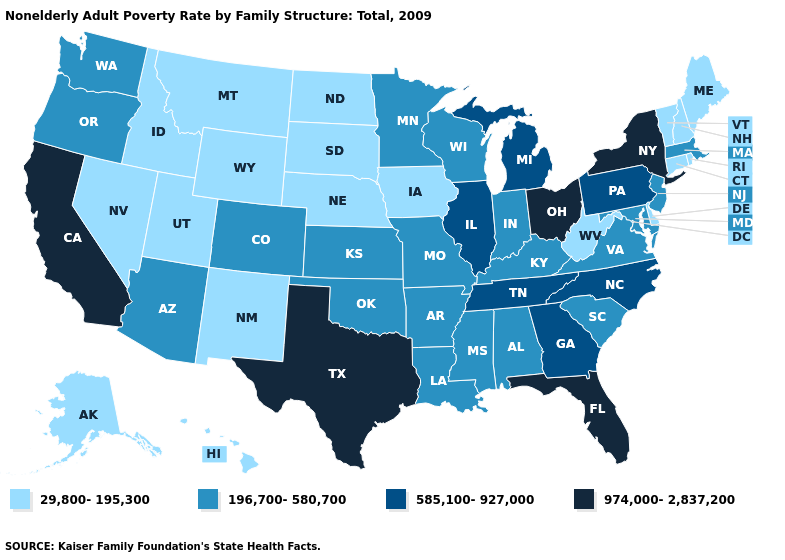What is the value of Michigan?
Be succinct. 585,100-927,000. Among the states that border Massachusetts , does Vermont have the highest value?
Give a very brief answer. No. Name the states that have a value in the range 29,800-195,300?
Concise answer only. Alaska, Connecticut, Delaware, Hawaii, Idaho, Iowa, Maine, Montana, Nebraska, Nevada, New Hampshire, New Mexico, North Dakota, Rhode Island, South Dakota, Utah, Vermont, West Virginia, Wyoming. What is the value of Washington?
Short answer required. 196,700-580,700. Does Idaho have a higher value than Iowa?
Give a very brief answer. No. Among the states that border Illinois , does Iowa have the highest value?
Answer briefly. No. What is the highest value in the USA?
Concise answer only. 974,000-2,837,200. Name the states that have a value in the range 29,800-195,300?
Write a very short answer. Alaska, Connecticut, Delaware, Hawaii, Idaho, Iowa, Maine, Montana, Nebraska, Nevada, New Hampshire, New Mexico, North Dakota, Rhode Island, South Dakota, Utah, Vermont, West Virginia, Wyoming. Name the states that have a value in the range 585,100-927,000?
Give a very brief answer. Georgia, Illinois, Michigan, North Carolina, Pennsylvania, Tennessee. Name the states that have a value in the range 196,700-580,700?
Give a very brief answer. Alabama, Arizona, Arkansas, Colorado, Indiana, Kansas, Kentucky, Louisiana, Maryland, Massachusetts, Minnesota, Mississippi, Missouri, New Jersey, Oklahoma, Oregon, South Carolina, Virginia, Washington, Wisconsin. What is the lowest value in the South?
Quick response, please. 29,800-195,300. Among the states that border New Jersey , which have the highest value?
Give a very brief answer. New York. What is the lowest value in the USA?
Be succinct. 29,800-195,300. Which states have the lowest value in the South?
Give a very brief answer. Delaware, West Virginia. Which states have the highest value in the USA?
Quick response, please. California, Florida, New York, Ohio, Texas. 